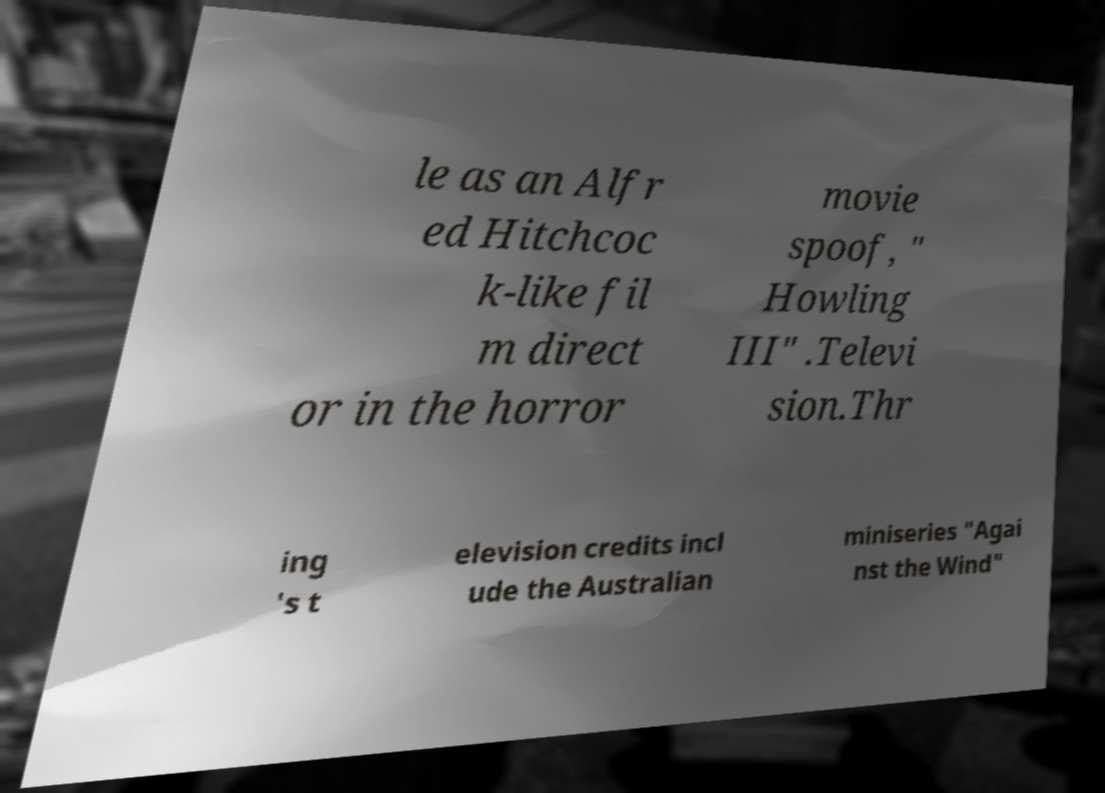For documentation purposes, I need the text within this image transcribed. Could you provide that? le as an Alfr ed Hitchcoc k-like fil m direct or in the horror movie spoof, " Howling III" .Televi sion.Thr ing 's t elevision credits incl ude the Australian miniseries "Agai nst the Wind" 